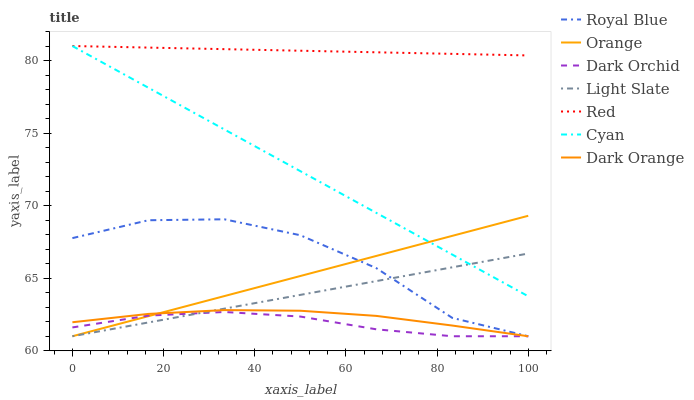Does Dark Orchid have the minimum area under the curve?
Answer yes or no. Yes. Does Red have the maximum area under the curve?
Answer yes or no. Yes. Does Light Slate have the minimum area under the curve?
Answer yes or no. No. Does Light Slate have the maximum area under the curve?
Answer yes or no. No. Is Red the smoothest?
Answer yes or no. Yes. Is Royal Blue the roughest?
Answer yes or no. Yes. Is Light Slate the smoothest?
Answer yes or no. No. Is Light Slate the roughest?
Answer yes or no. No. Does Dark Orange have the lowest value?
Answer yes or no. Yes. Does Cyan have the lowest value?
Answer yes or no. No. Does Red have the highest value?
Answer yes or no. Yes. Does Light Slate have the highest value?
Answer yes or no. No. Is Dark Orange less than Red?
Answer yes or no. Yes. Is Red greater than Dark Orchid?
Answer yes or no. Yes. Does Light Slate intersect Royal Blue?
Answer yes or no. Yes. Is Light Slate less than Royal Blue?
Answer yes or no. No. Is Light Slate greater than Royal Blue?
Answer yes or no. No. Does Dark Orange intersect Red?
Answer yes or no. No. 